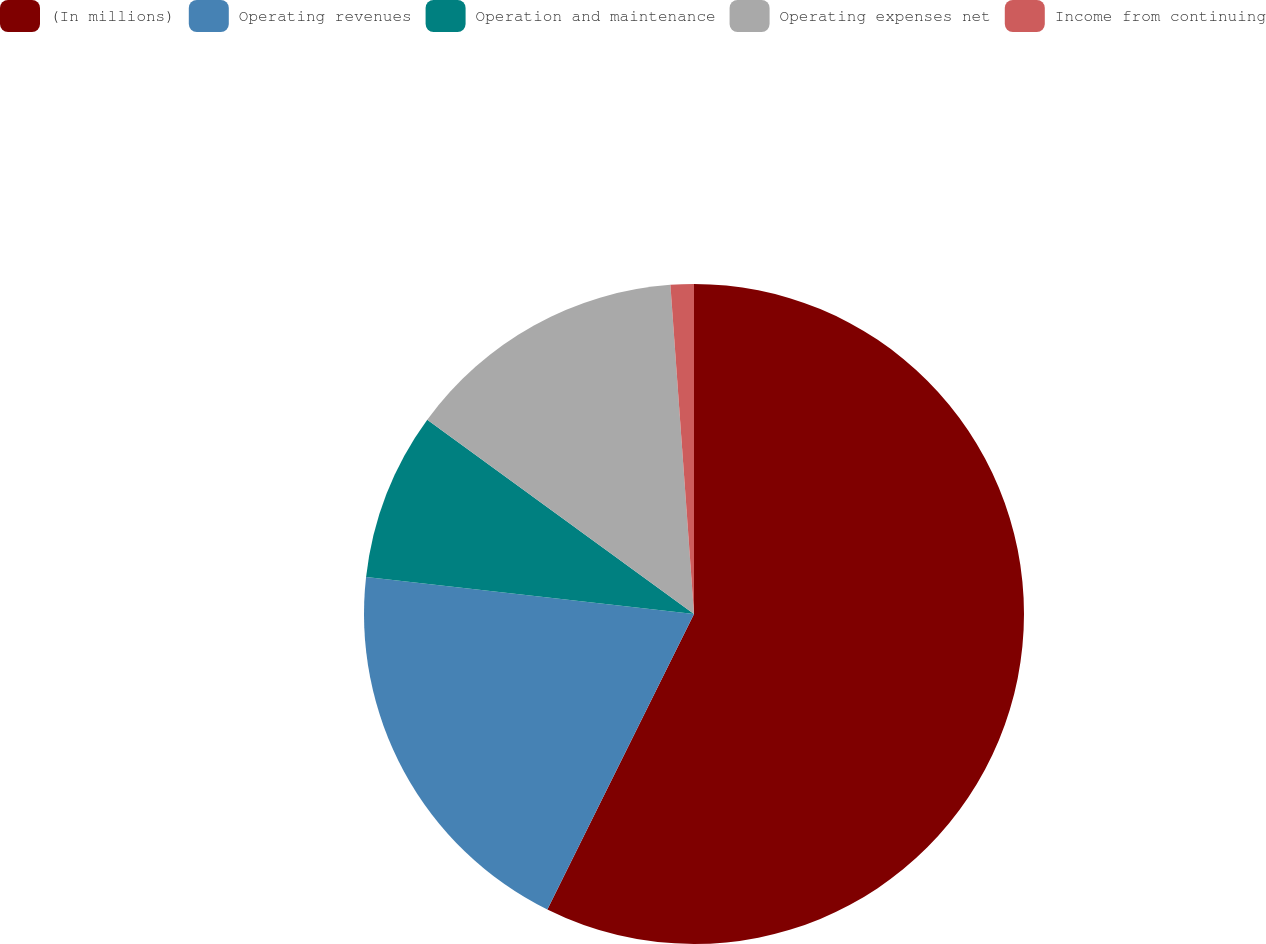Convert chart to OTSL. <chart><loc_0><loc_0><loc_500><loc_500><pie_chart><fcel>(In millions)<fcel>Operating revenues<fcel>Operation and maintenance<fcel>Operating expenses net<fcel>Income from continuing<nl><fcel>57.33%<fcel>19.46%<fcel>8.23%<fcel>13.84%<fcel>1.14%<nl></chart> 